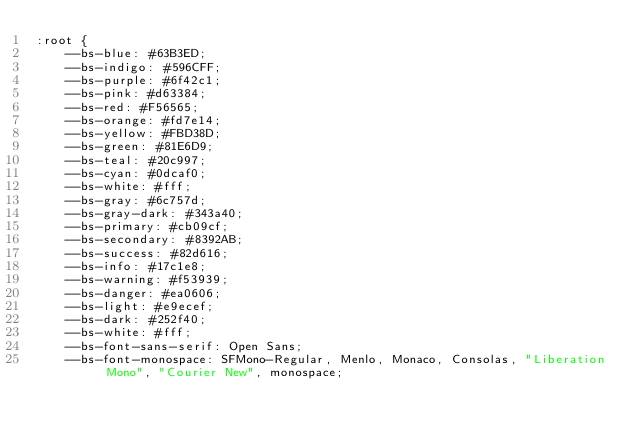Convert code to text. <code><loc_0><loc_0><loc_500><loc_500><_CSS_>:root {
    --bs-blue: #63B3ED;
    --bs-indigo: #596CFF;
    --bs-purple: #6f42c1;
    --bs-pink: #d63384;
    --bs-red: #F56565;
    --bs-orange: #fd7e14;
    --bs-yellow: #FBD38D;
    --bs-green: #81E6D9;
    --bs-teal: #20c997;
    --bs-cyan: #0dcaf0;
    --bs-white: #fff;
    --bs-gray: #6c757d;
    --bs-gray-dark: #343a40;
    --bs-primary: #cb09cf;
    --bs-secondary: #8392AB;
    --bs-success: #82d616;
    --bs-info: #17c1e8;
    --bs-warning: #f53939;
    --bs-danger: #ea0606;
    --bs-light: #e9ecef;
    --bs-dark: #252f40;
    --bs-white: #fff;
    --bs-font-sans-serif: Open Sans;
    --bs-font-monospace: SFMono-Regular, Menlo, Monaco, Consolas, "Liberation Mono", "Courier New", monospace;</code> 